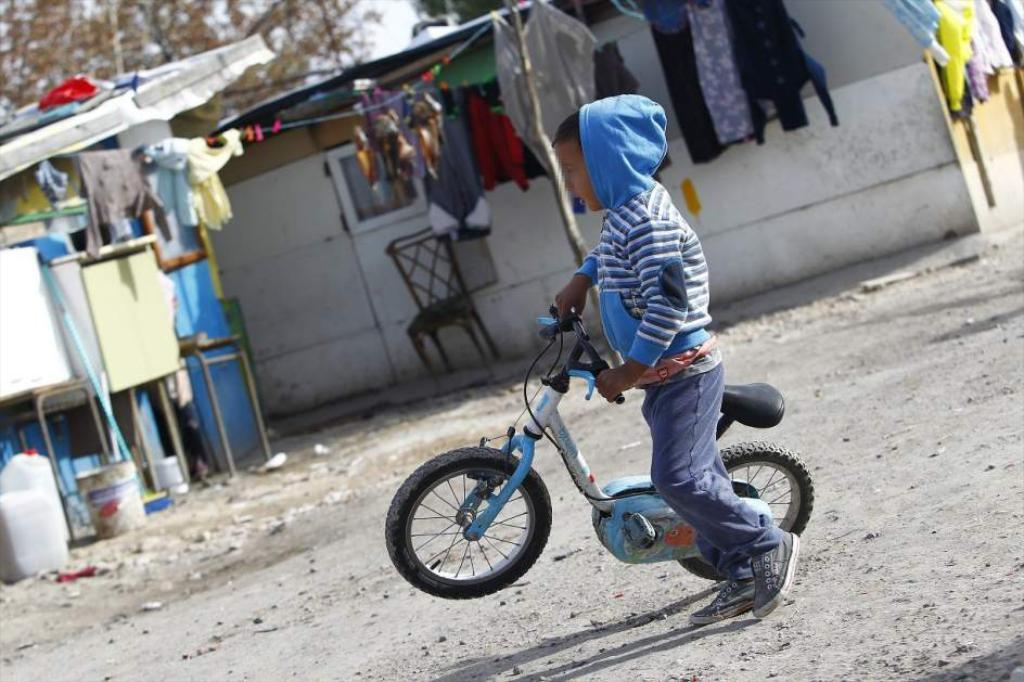Who is in the image? There is a boy in the image. What is the boy doing in the image? The boy is standing and holding a bicycle. What structure is visible in the image? There is a shed in the image. What is hanging outside the shed? Clothes are hanging outside on a rope attached to the shed. What type of vegetation is present in the image? There are trees in the image. What type of dirt can be seen on the boy's hand in the image? There is no dirt visible on the boy's hand in the image. How many socks is the boy wearing in the image? The image does not show the boy's socks, so it cannot be determined how many he is wearing. 